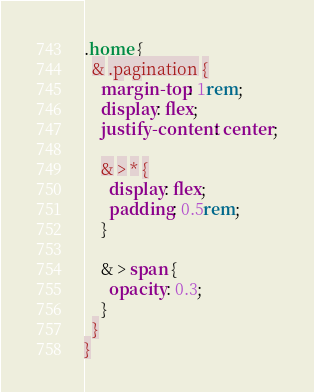Convert code to text. <code><loc_0><loc_0><loc_500><loc_500><_CSS_>.home {
  & .pagination {
    margin-top: 1rem;
    display: flex;
    justify-content: center;
    
    & > * {
      display: flex;
      padding: 0.5rem;
    }

    & > span {
      opacity: 0.3;
    }
  }
}
</code> 